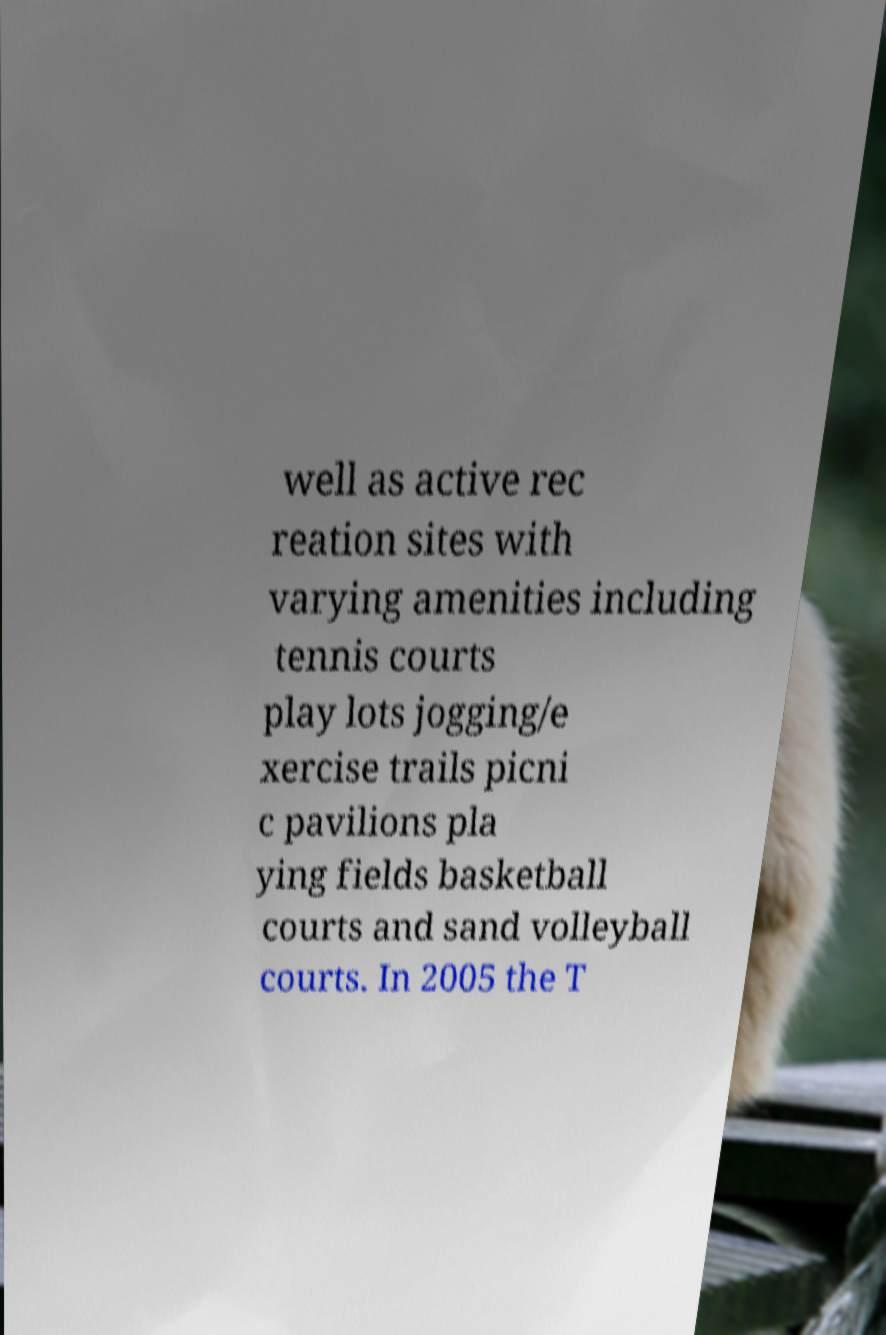Please identify and transcribe the text found in this image. well as active rec reation sites with varying amenities including tennis courts play lots jogging/e xercise trails picni c pavilions pla ying fields basketball courts and sand volleyball courts. In 2005 the T 